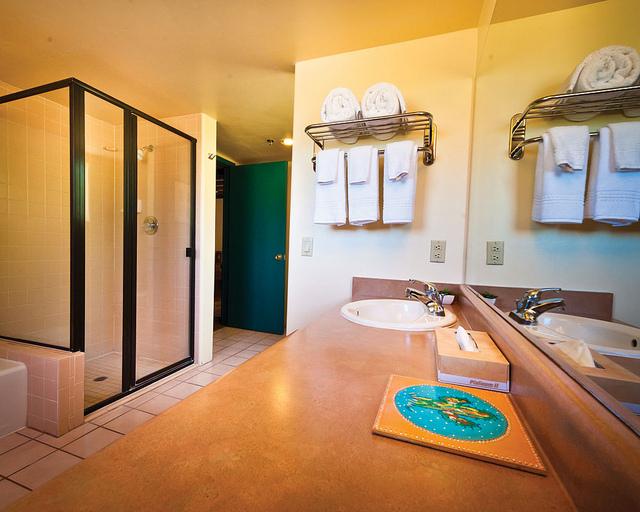How many towels are seen?
Answer briefly. 8. Is the bathroom tidy?
Keep it brief. Yes. What room is this?
Give a very brief answer. Bathroom. 